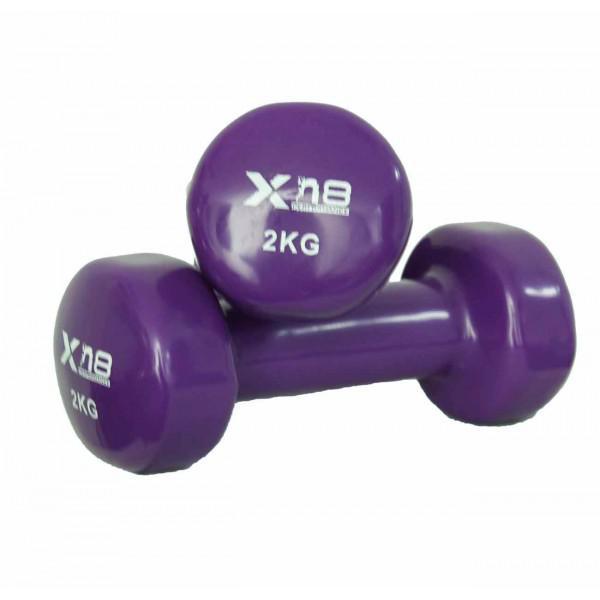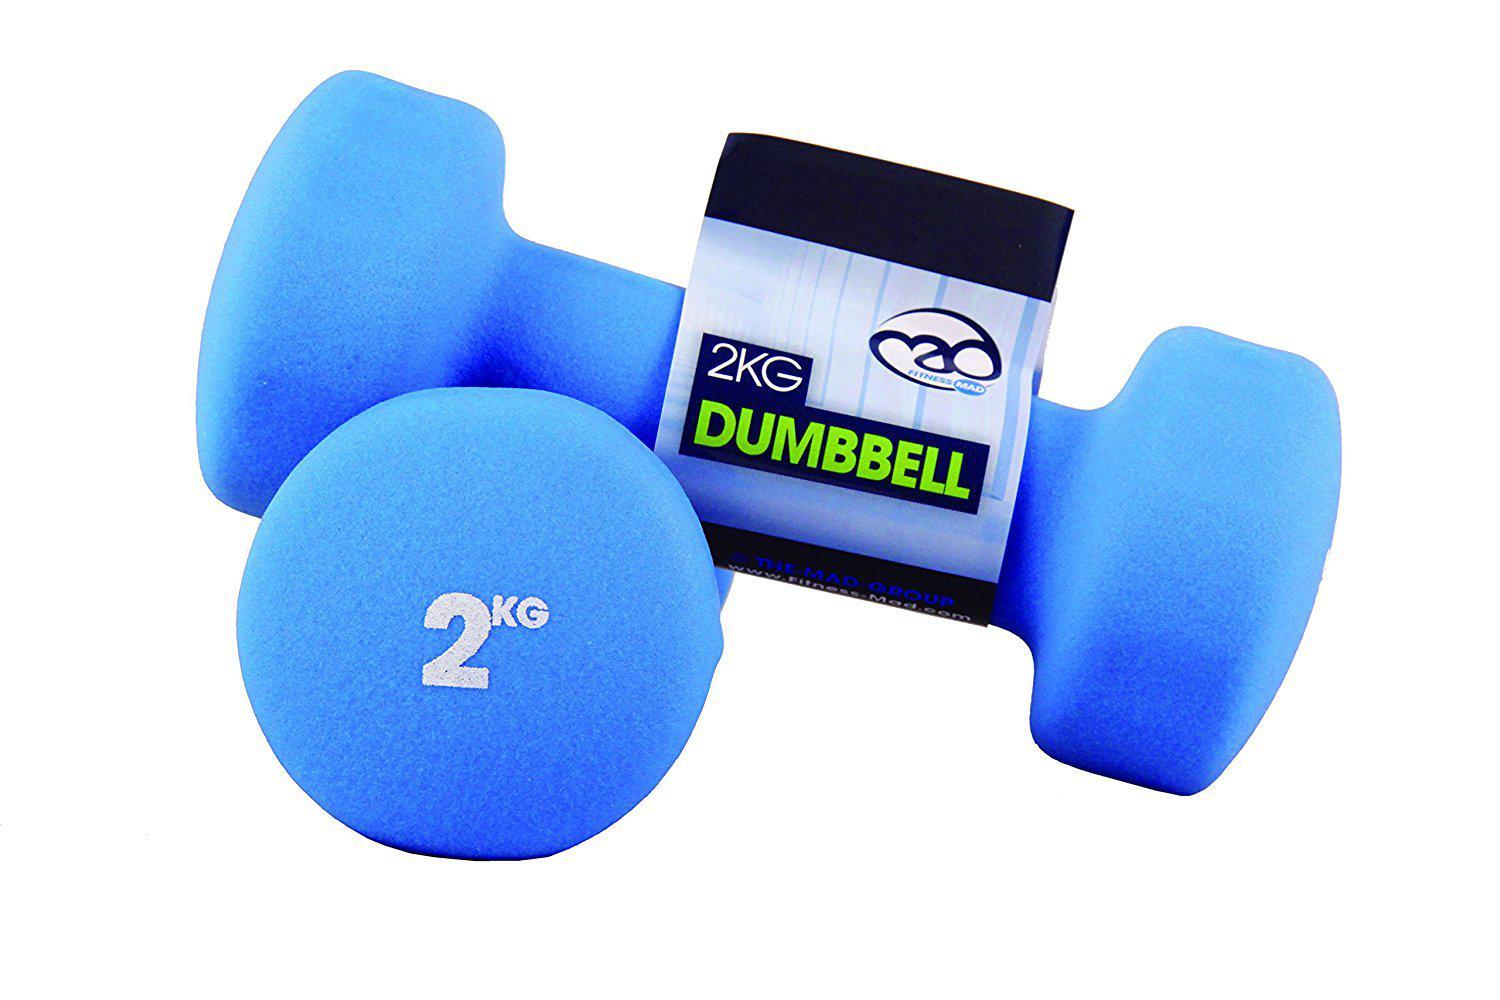The first image is the image on the left, the second image is the image on the right. Considering the images on both sides, is "Each image shows two dumbbells, and right and left images show the same color weights." valid? Answer yes or no. No. The first image is the image on the left, the second image is the image on the right. Assess this claim about the two images: "The pair of dumbells in the left image is the same color as the pair of dumbells in the right image.". Correct or not? Answer yes or no. No. 